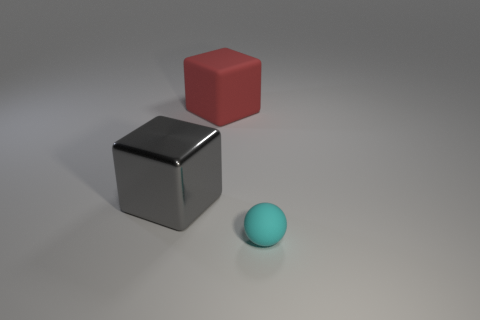What number of other big objects have the same shape as the cyan matte object?
Provide a short and direct response. 0. The cyan thing that is the same material as the large red cube is what shape?
Your answer should be very brief. Sphere. What material is the object to the right of the matte thing that is behind the big block to the left of the big red thing made of?
Offer a terse response. Rubber. Is the size of the gray shiny block the same as the object that is right of the big red cube?
Your response must be concise. No. There is a big red object that is the same shape as the gray object; what material is it?
Offer a very short reply. Rubber. What is the size of the thing that is on the left side of the rubber object that is to the left of the matte thing in front of the red thing?
Provide a succinct answer. Large. Do the gray block and the cyan ball have the same size?
Your answer should be very brief. No. What material is the object that is on the right side of the matte object behind the cyan object?
Your response must be concise. Rubber. Is the shape of the rubber object in front of the shiny cube the same as the thing that is left of the matte cube?
Provide a short and direct response. No. Is the number of big gray cubes that are on the left side of the big matte cube the same as the number of large gray objects?
Your answer should be very brief. Yes. 